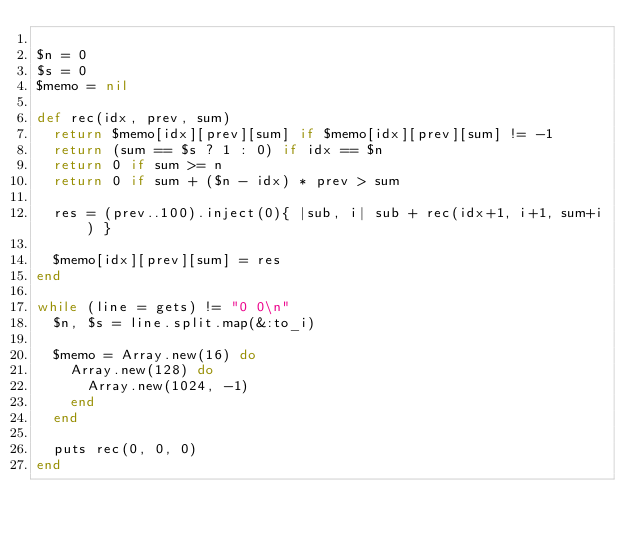<code> <loc_0><loc_0><loc_500><loc_500><_Ruby_>
$n = 0
$s = 0
$memo = nil

def rec(idx, prev, sum)
  return $memo[idx][prev][sum] if $memo[idx][prev][sum] != -1
  return (sum == $s ? 1 : 0) if idx == $n
  return 0 if sum >= n
  return 0 if sum + ($n - idx) * prev > sum

  res = (prev..100).inject(0){ |sub, i| sub + rec(idx+1, i+1, sum+i) }

  $memo[idx][prev][sum] = res
end

while (line = gets) != "0 0\n"
  $n, $s = line.split.map(&:to_i)

  $memo = Array.new(16) do
    Array.new(128) do
      Array.new(1024, -1)
    end
  end

  puts rec(0, 0, 0)
end</code> 